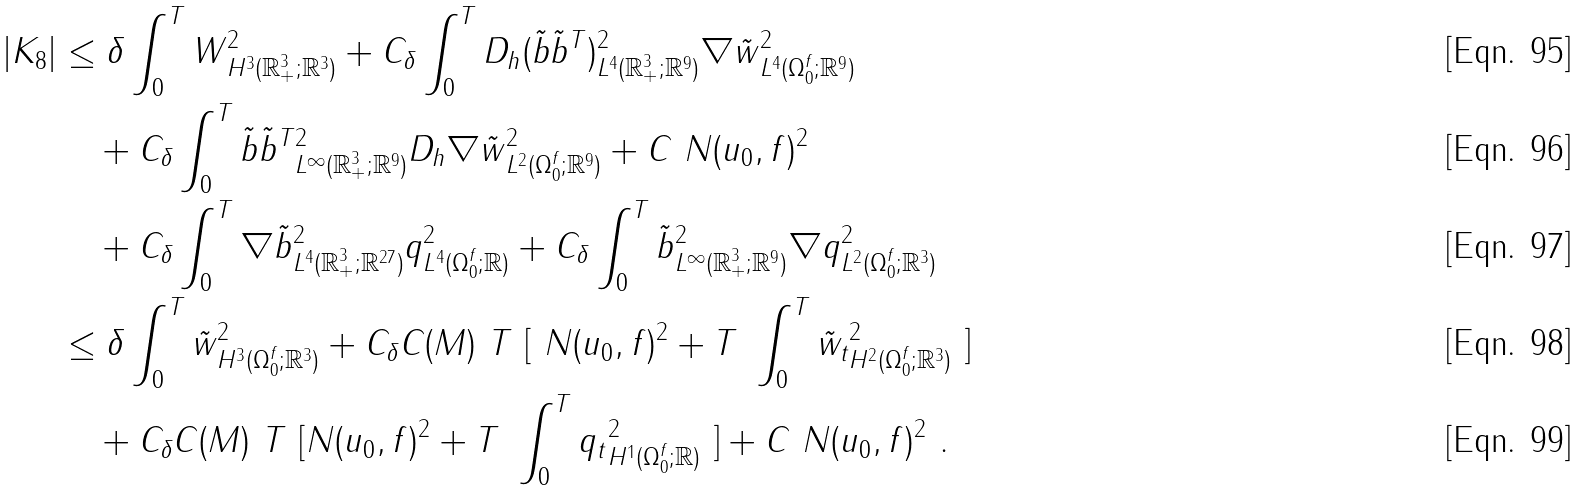<formula> <loc_0><loc_0><loc_500><loc_500>| K _ { 8 } | & \leq \delta \int _ { 0 } ^ { T } \| W \| ^ { 2 } _ { H ^ { 3 } ( { \mathbb { R } } ^ { 3 } _ { + } ; { \mathbb { R } } ^ { 3 } ) } + C _ { \delta } \int _ { 0 } ^ { T } \| D _ { h } ( \tilde { b } \tilde { b } ^ { T } ) \| ^ { 2 } _ { L ^ { 4 } ( { \mathbb { R } } ^ { 3 } _ { + } ; { \mathbb { R } } ^ { 9 } ) } \| \nabla \tilde { w } \| ^ { 2 } _ { L ^ { 4 } ( \Omega _ { 0 } ^ { f } ; { \mathbb { R } } ^ { 9 } ) } \\ & \quad + C _ { \delta } \int _ { 0 } ^ { T } \| \tilde { b } \tilde { b } ^ { T } \| ^ { 2 } _ { L ^ { \infty } ( { \mathbb { R } } ^ { 3 } _ { + } ; { \mathbb { R } } ^ { 9 } ) } \| D _ { h } \nabla \tilde { w } \| ^ { 2 } _ { L ^ { 2 } ( \Omega _ { 0 } ^ { f } ; { \mathbb { R } } ^ { 9 } ) } + C \ N ( u _ { 0 } , f ) ^ { 2 } \\ & \quad + C _ { \delta } \int _ { 0 } ^ { T } \| \nabla \tilde { b } \| ^ { 2 } _ { L ^ { 4 } ( { \mathbb { R } } ^ { 3 } _ { + } ; { \mathbb { R } } ^ { 2 7 } ) } \| q \| ^ { 2 } _ { L ^ { 4 } ( \Omega _ { 0 } ^ { f } ; { \mathbb { R } } ) } + C _ { \delta } \int _ { 0 } ^ { T } \| \tilde { b } \| ^ { 2 } _ { L ^ { \infty } ( { \mathbb { R } } ^ { 3 } _ { + } ; { \mathbb { R } } ^ { 9 } ) } \| \nabla q \| ^ { 2 } _ { L ^ { 2 } ( \Omega _ { 0 } ^ { f } ; { \mathbb { R } } ^ { 3 } ) } \\ & \leq \delta \int _ { 0 } ^ { T } \| \tilde { w } \| ^ { 2 } _ { H ^ { 3 } ( \Omega _ { 0 } ^ { f } ; { \mathbb { R } } ^ { 3 } ) } + C _ { \delta } C ( M ) \ T \ [ \ N ( u _ { 0 } , f ) ^ { 2 } + T \ \int _ { 0 } ^ { T } \| \tilde { w } _ { t } \| ^ { 2 } _ { H ^ { 2 } ( \Omega _ { 0 } ^ { f } ; { \mathbb { R } } ^ { 3 } ) } \ ] \\ & \quad + C _ { \delta } C ( M ) \ T \ [ N ( u _ { 0 } , f ) ^ { 2 } + T \ \int _ { 0 } ^ { T } \| q _ { t } \| ^ { 2 } _ { H ^ { 1 } ( \Omega _ { 0 } ^ { f } ; { \mathbb { R } } ) } \ ] + C \ N ( u _ { 0 } , f ) ^ { 2 } \ .</formula> 